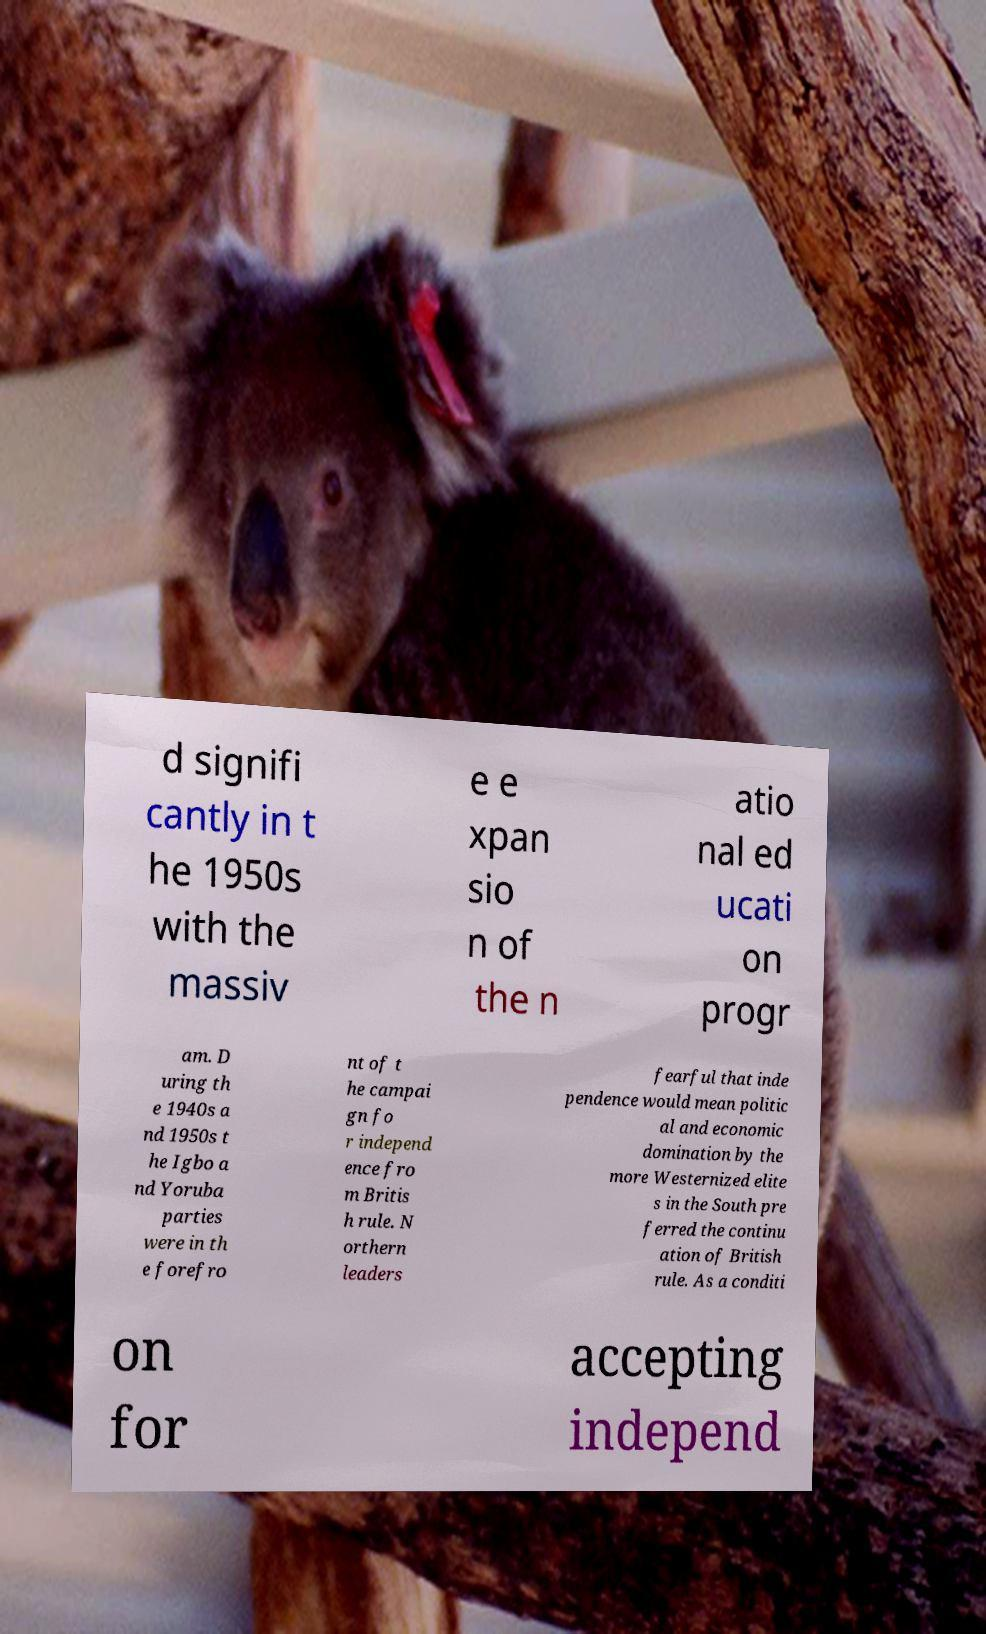There's text embedded in this image that I need extracted. Can you transcribe it verbatim? d signifi cantly in t he 1950s with the massiv e e xpan sio n of the n atio nal ed ucati on progr am. D uring th e 1940s a nd 1950s t he Igbo a nd Yoruba parties were in th e forefro nt of t he campai gn fo r independ ence fro m Britis h rule. N orthern leaders fearful that inde pendence would mean politic al and economic domination by the more Westernized elite s in the South pre ferred the continu ation of British rule. As a conditi on for accepting independ 